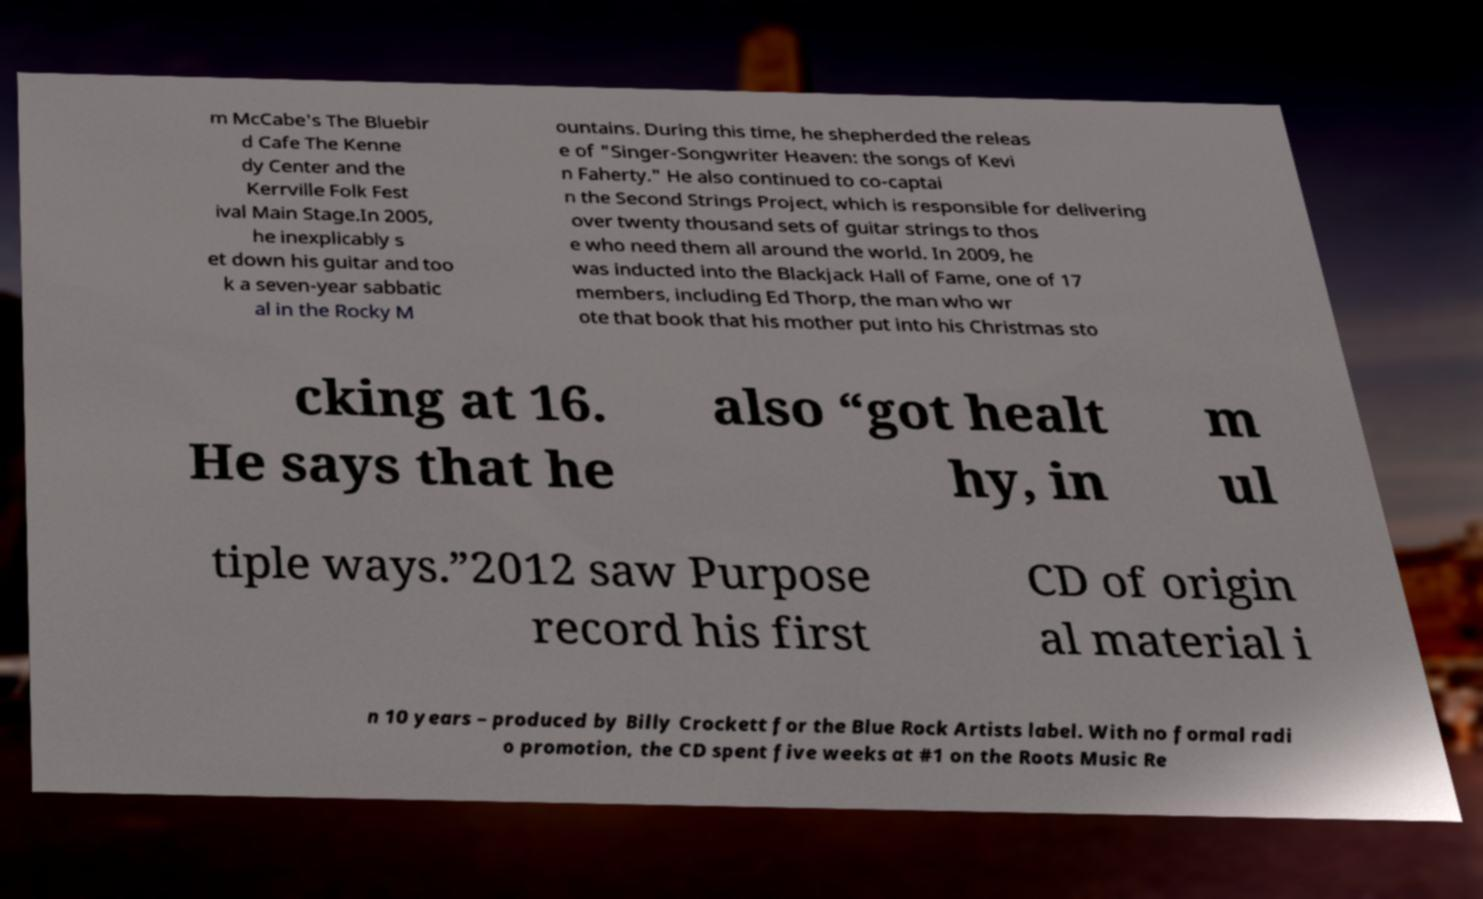Can you accurately transcribe the text from the provided image for me? m McCabe's The Bluebir d Cafe The Kenne dy Center and the Kerrville Folk Fest ival Main Stage.In 2005, he inexplicably s et down his guitar and too k a seven-year sabbatic al in the Rocky M ountains. During this time, he shepherded the releas e of "Singer-Songwriter Heaven: the songs of Kevi n Faherty." He also continued to co-captai n the Second Strings Project, which is responsible for delivering over twenty thousand sets of guitar strings to thos e who need them all around the world. In 2009, he was inducted into the Blackjack Hall of Fame, one of 17 members, including Ed Thorp, the man who wr ote that book that his mother put into his Christmas sto cking at 16. He says that he also “got healt hy, in m ul tiple ways.”2012 saw Purpose record his first CD of origin al material i n 10 years – produced by Billy Crockett for the Blue Rock Artists label. With no formal radi o promotion, the CD spent five weeks at #1 on the Roots Music Re 